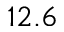<formula> <loc_0><loc_0><loc_500><loc_500>1 2 . 6</formula> 